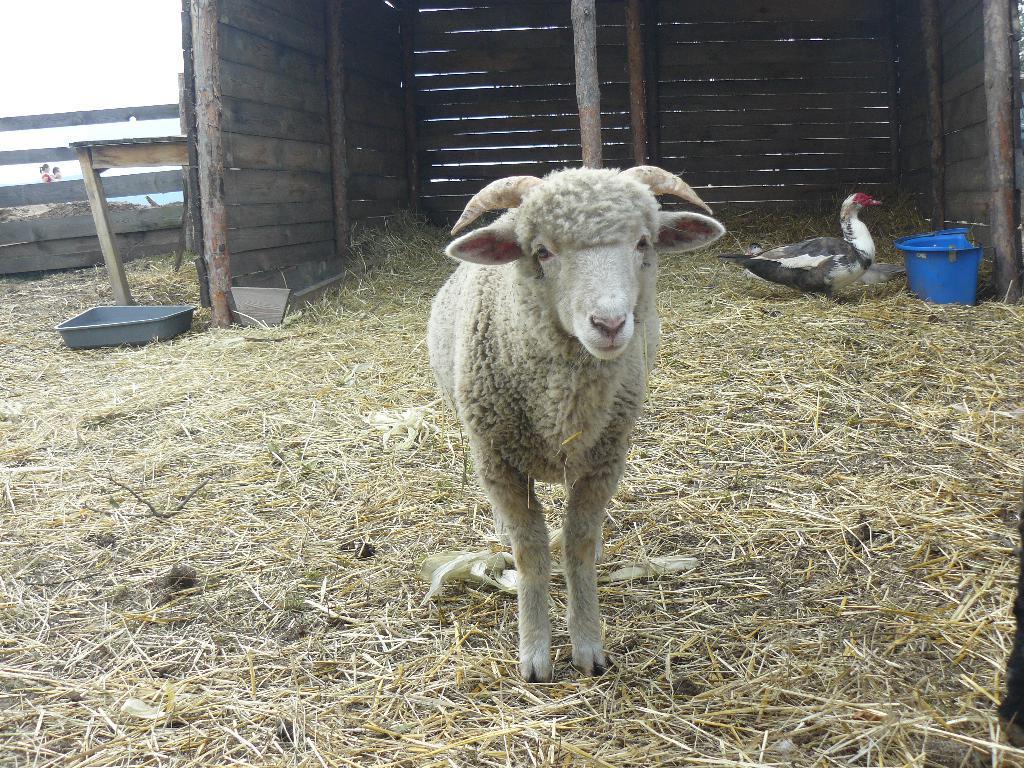How would you summarize this image in a sentence or two? In this picture we can see a sheep. On the right side we can see a bird is near to a blue container. In the background we can see people and a wooden shelter. There are few objects, dried grass on the ground. 